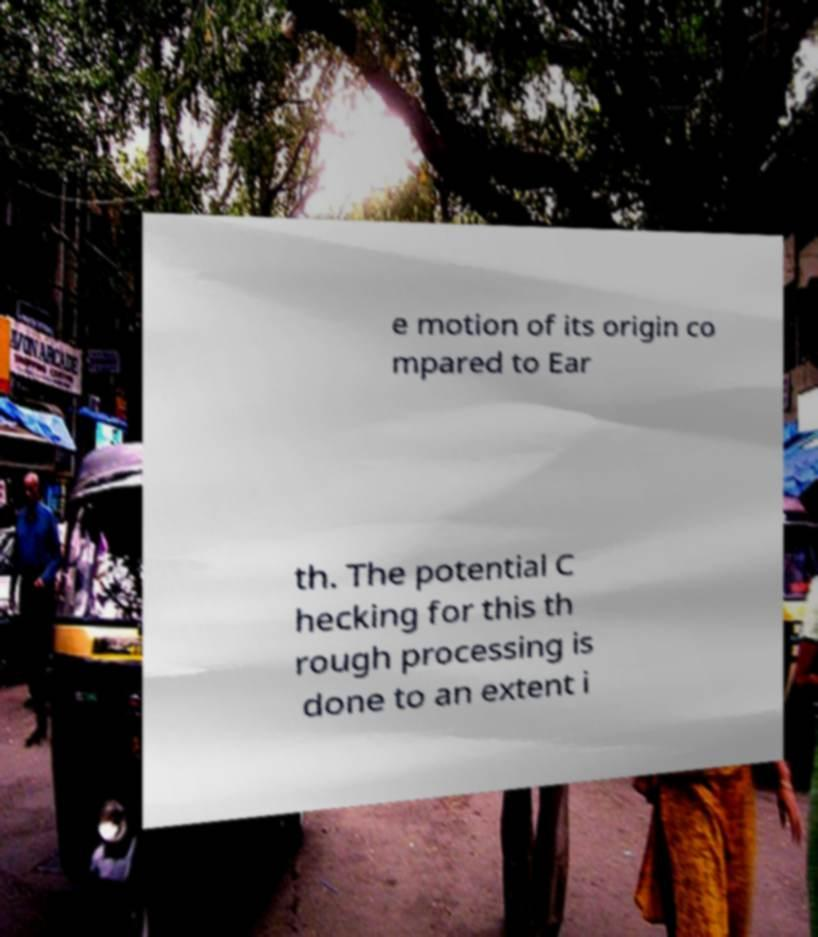What messages or text are displayed in this image? I need them in a readable, typed format. e motion of its origin co mpared to Ear th. The potential C hecking for this th rough processing is done to an extent i 